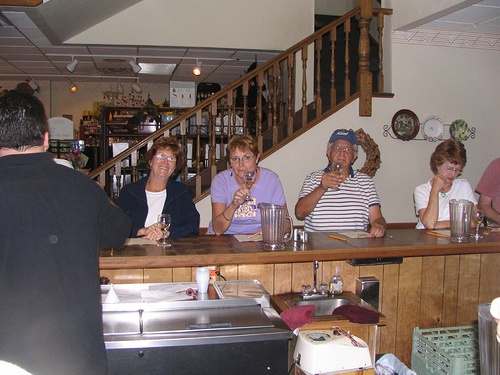Describe the objects in this image and their specific colors. I can see people in maroon, gray, and black tones, refrigerator in maroon, black, gray, and lavender tones, people in maroon, brown, lightgray, gray, and darkgray tones, people in maroon, black, salmon, and lavender tones, and people in maroon, violet, and brown tones in this image. 